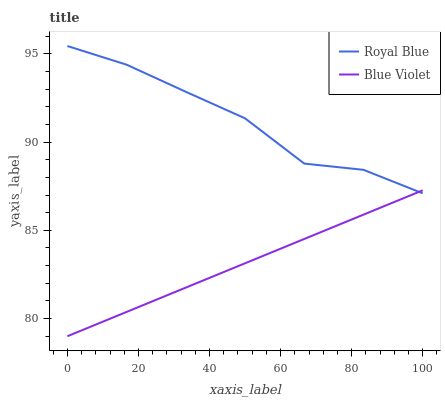Does Blue Violet have the maximum area under the curve?
Answer yes or no. No. Is Blue Violet the roughest?
Answer yes or no. No. Does Blue Violet have the highest value?
Answer yes or no. No. 